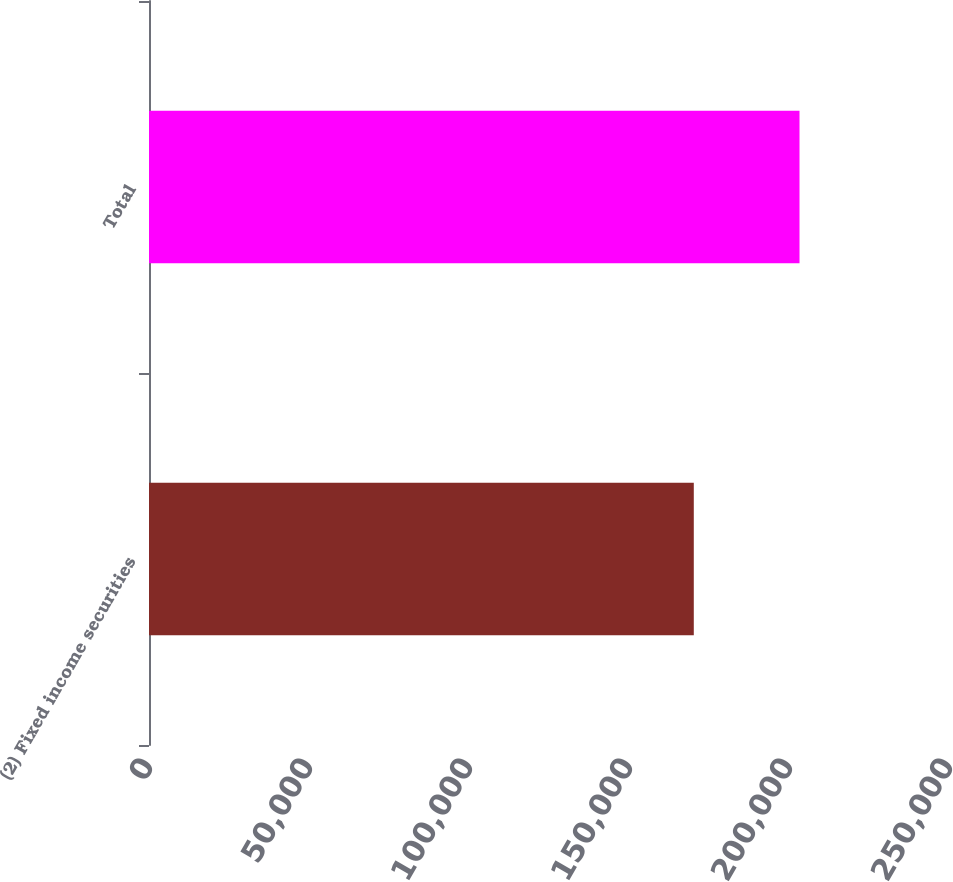Convert chart. <chart><loc_0><loc_0><loc_500><loc_500><bar_chart><fcel>(2) Fixed income securities<fcel>Total<nl><fcel>170249<fcel>203285<nl></chart> 